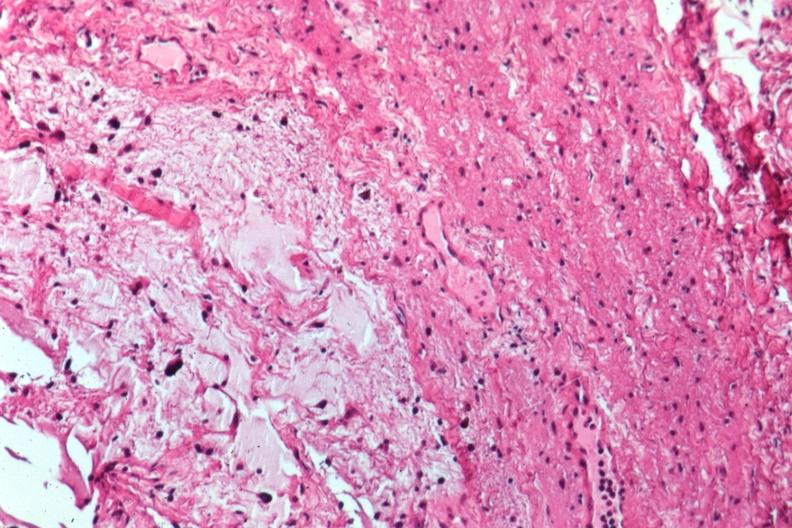does this image show glioma?
Answer the question using a single word or phrase. Yes 